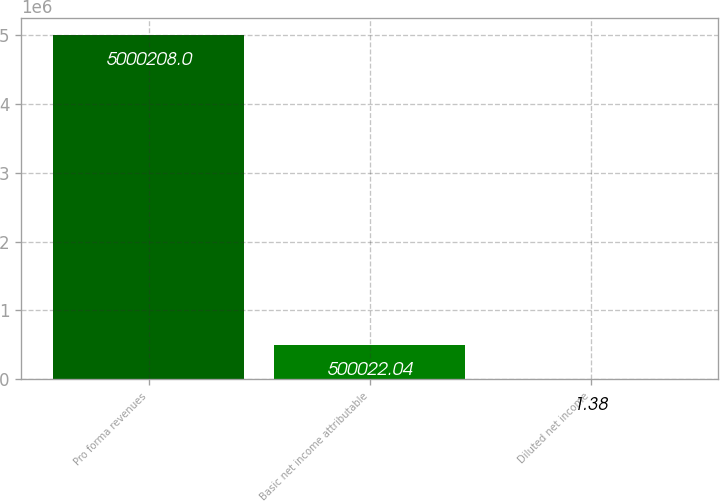Convert chart to OTSL. <chart><loc_0><loc_0><loc_500><loc_500><bar_chart><fcel>Pro forma revenues<fcel>Basic net income attributable<fcel>Diluted net income<nl><fcel>5.00021e+06<fcel>500022<fcel>1.38<nl></chart> 